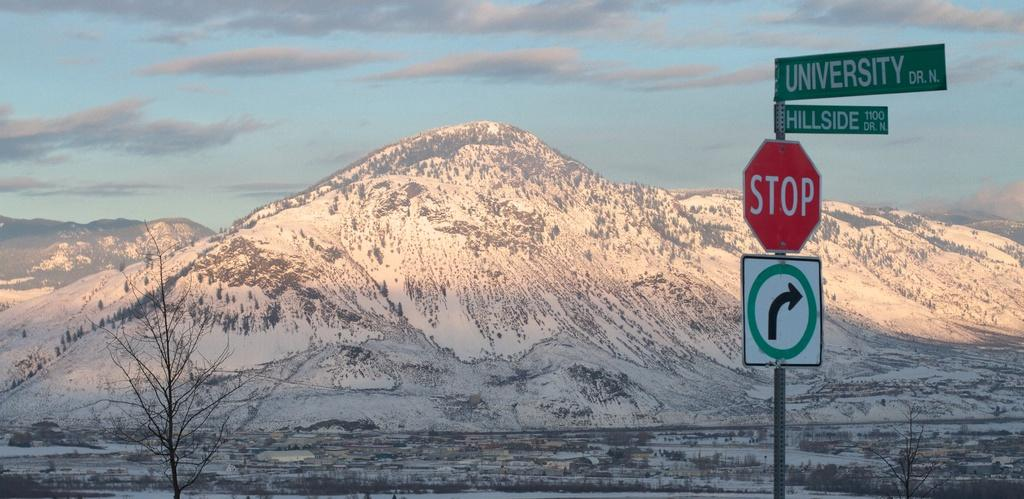<image>
Give a short and clear explanation of the subsequent image. A stop sign is beneath the intersection of University and Hillside. 